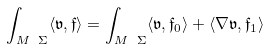<formula> <loc_0><loc_0><loc_500><loc_500>\int _ { M \ \Sigma } \langle \mathfrak { v } , \mathfrak { f } \rangle = \int _ { M \ \Sigma } \langle \mathfrak { v } , \mathfrak { f } _ { 0 } \rangle + \langle \nabla \mathfrak { v } , \mathfrak { f } _ { 1 } \rangle</formula> 